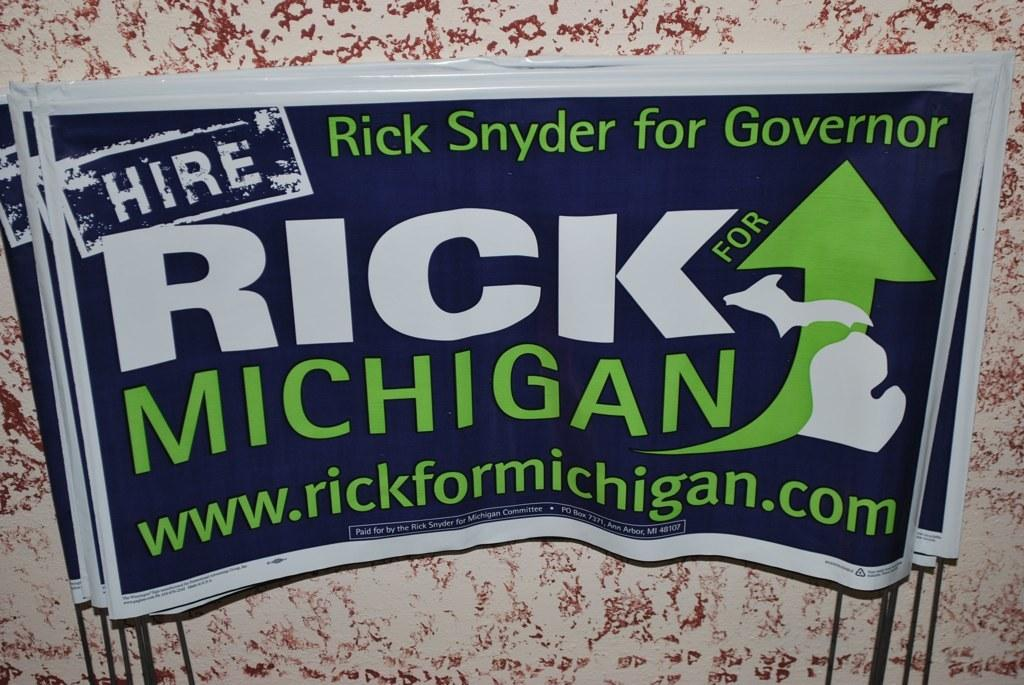<image>
Provide a brief description of the given image. Sign that says: Hire Rick Snyder for Governor, Rick for Michigan, www.rickformichigan.com. 